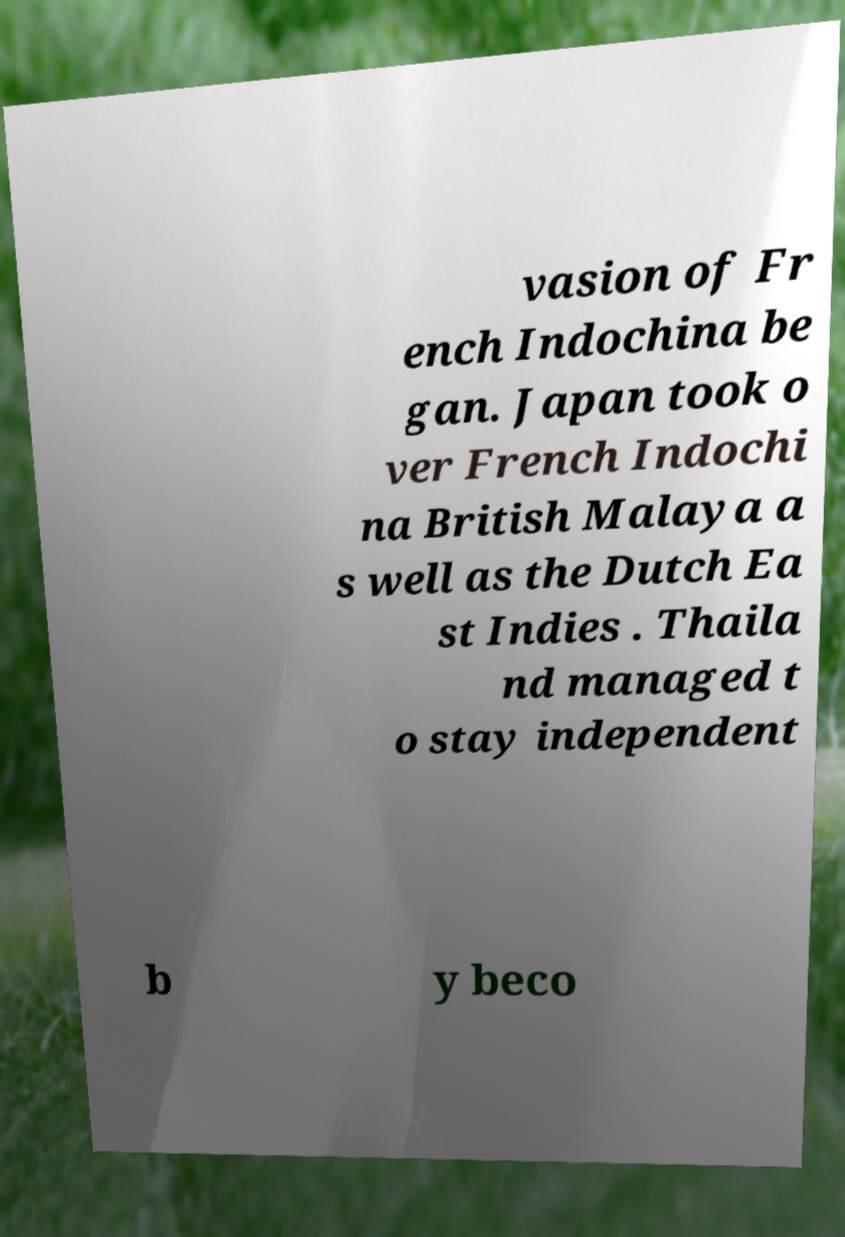Can you accurately transcribe the text from the provided image for me? vasion of Fr ench Indochina be gan. Japan took o ver French Indochi na British Malaya a s well as the Dutch Ea st Indies . Thaila nd managed t o stay independent b y beco 